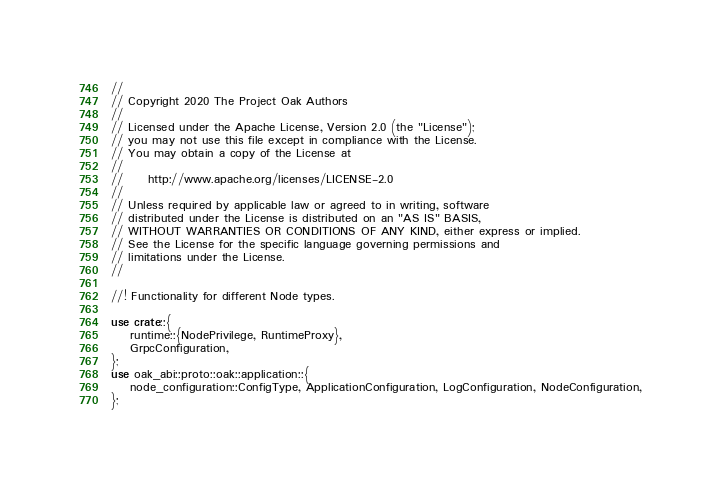<code> <loc_0><loc_0><loc_500><loc_500><_Rust_>//
// Copyright 2020 The Project Oak Authors
//
// Licensed under the Apache License, Version 2.0 (the "License");
// you may not use this file except in compliance with the License.
// You may obtain a copy of the License at
//
//     http://www.apache.org/licenses/LICENSE-2.0
//
// Unless required by applicable law or agreed to in writing, software
// distributed under the License is distributed on an "AS IS" BASIS,
// WITHOUT WARRANTIES OR CONDITIONS OF ANY KIND, either express or implied.
// See the License for the specific language governing permissions and
// limitations under the License.
//

//! Functionality for different Node types.

use crate::{
    runtime::{NodePrivilege, RuntimeProxy},
    GrpcConfiguration,
};
use oak_abi::proto::oak::application::{
    node_configuration::ConfigType, ApplicationConfiguration, LogConfiguration, NodeConfiguration,
};</code> 